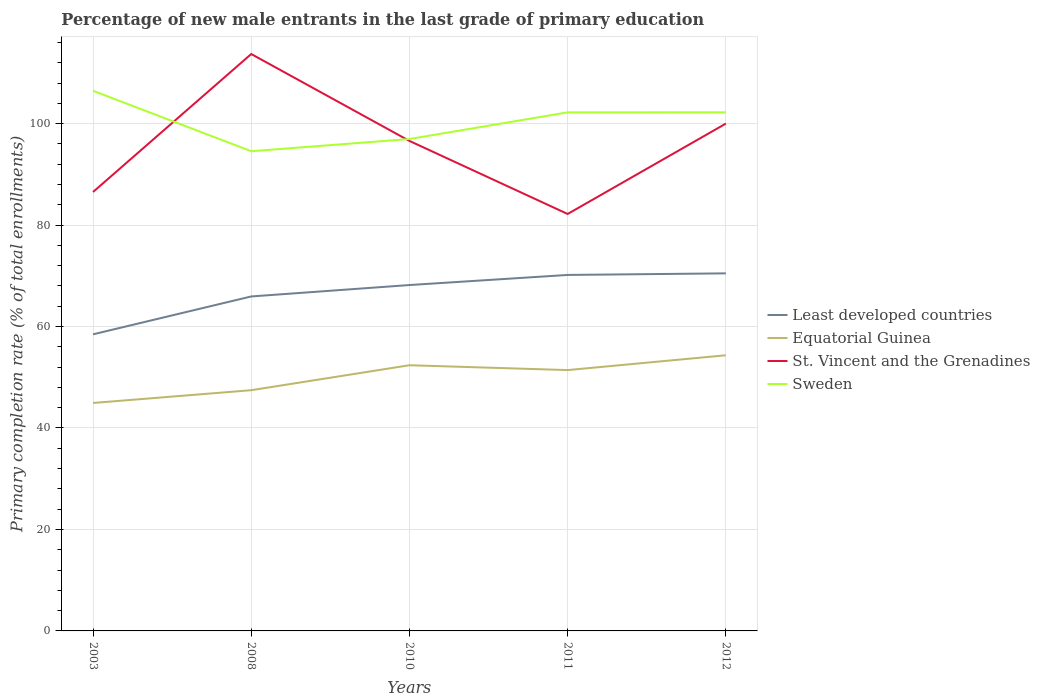Does the line corresponding to Least developed countries intersect with the line corresponding to St. Vincent and the Grenadines?
Your answer should be very brief. No. Is the number of lines equal to the number of legend labels?
Your response must be concise. Yes. Across all years, what is the maximum percentage of new male entrants in Least developed countries?
Your response must be concise. 58.46. What is the total percentage of new male entrants in Equatorial Guinea in the graph?
Your answer should be compact. -6.88. What is the difference between the highest and the second highest percentage of new male entrants in St. Vincent and the Grenadines?
Offer a terse response. 31.53. Is the percentage of new male entrants in Least developed countries strictly greater than the percentage of new male entrants in Sweden over the years?
Offer a very short reply. Yes. How many years are there in the graph?
Offer a very short reply. 5. Are the values on the major ticks of Y-axis written in scientific E-notation?
Your answer should be very brief. No. Does the graph contain any zero values?
Give a very brief answer. No. How are the legend labels stacked?
Keep it short and to the point. Vertical. What is the title of the graph?
Your answer should be compact. Percentage of new male entrants in the last grade of primary education. What is the label or title of the X-axis?
Ensure brevity in your answer.  Years. What is the label or title of the Y-axis?
Your answer should be very brief. Primary completion rate (% of total enrollments). What is the Primary completion rate (% of total enrollments) of Least developed countries in 2003?
Your answer should be compact. 58.46. What is the Primary completion rate (% of total enrollments) of Equatorial Guinea in 2003?
Your answer should be compact. 44.93. What is the Primary completion rate (% of total enrollments) in St. Vincent and the Grenadines in 2003?
Your answer should be very brief. 86.52. What is the Primary completion rate (% of total enrollments) of Sweden in 2003?
Offer a very short reply. 106.47. What is the Primary completion rate (% of total enrollments) of Least developed countries in 2008?
Your response must be concise. 65.93. What is the Primary completion rate (% of total enrollments) in Equatorial Guinea in 2008?
Provide a succinct answer. 47.45. What is the Primary completion rate (% of total enrollments) in St. Vincent and the Grenadines in 2008?
Your answer should be very brief. 113.72. What is the Primary completion rate (% of total enrollments) in Sweden in 2008?
Provide a succinct answer. 94.56. What is the Primary completion rate (% of total enrollments) in Least developed countries in 2010?
Keep it short and to the point. 68.18. What is the Primary completion rate (% of total enrollments) in Equatorial Guinea in 2010?
Your response must be concise. 52.37. What is the Primary completion rate (% of total enrollments) in St. Vincent and the Grenadines in 2010?
Your answer should be very brief. 96.59. What is the Primary completion rate (% of total enrollments) of Sweden in 2010?
Offer a terse response. 96.96. What is the Primary completion rate (% of total enrollments) in Least developed countries in 2011?
Your response must be concise. 70.17. What is the Primary completion rate (% of total enrollments) in Equatorial Guinea in 2011?
Make the answer very short. 51.42. What is the Primary completion rate (% of total enrollments) in St. Vincent and the Grenadines in 2011?
Ensure brevity in your answer.  82.19. What is the Primary completion rate (% of total enrollments) of Sweden in 2011?
Make the answer very short. 102.22. What is the Primary completion rate (% of total enrollments) of Least developed countries in 2012?
Provide a succinct answer. 70.48. What is the Primary completion rate (% of total enrollments) of Equatorial Guinea in 2012?
Offer a very short reply. 54.34. What is the Primary completion rate (% of total enrollments) of St. Vincent and the Grenadines in 2012?
Make the answer very short. 100. What is the Primary completion rate (% of total enrollments) of Sweden in 2012?
Provide a short and direct response. 102.23. Across all years, what is the maximum Primary completion rate (% of total enrollments) of Least developed countries?
Provide a short and direct response. 70.48. Across all years, what is the maximum Primary completion rate (% of total enrollments) of Equatorial Guinea?
Your answer should be compact. 54.34. Across all years, what is the maximum Primary completion rate (% of total enrollments) of St. Vincent and the Grenadines?
Provide a short and direct response. 113.72. Across all years, what is the maximum Primary completion rate (% of total enrollments) of Sweden?
Your response must be concise. 106.47. Across all years, what is the minimum Primary completion rate (% of total enrollments) of Least developed countries?
Provide a succinct answer. 58.46. Across all years, what is the minimum Primary completion rate (% of total enrollments) of Equatorial Guinea?
Give a very brief answer. 44.93. Across all years, what is the minimum Primary completion rate (% of total enrollments) of St. Vincent and the Grenadines?
Keep it short and to the point. 82.19. Across all years, what is the minimum Primary completion rate (% of total enrollments) of Sweden?
Your answer should be very brief. 94.56. What is the total Primary completion rate (% of total enrollments) of Least developed countries in the graph?
Give a very brief answer. 333.22. What is the total Primary completion rate (% of total enrollments) of Equatorial Guinea in the graph?
Ensure brevity in your answer.  250.51. What is the total Primary completion rate (% of total enrollments) in St. Vincent and the Grenadines in the graph?
Offer a terse response. 479.01. What is the total Primary completion rate (% of total enrollments) in Sweden in the graph?
Keep it short and to the point. 502.44. What is the difference between the Primary completion rate (% of total enrollments) in Least developed countries in 2003 and that in 2008?
Keep it short and to the point. -7.47. What is the difference between the Primary completion rate (% of total enrollments) of Equatorial Guinea in 2003 and that in 2008?
Make the answer very short. -2.52. What is the difference between the Primary completion rate (% of total enrollments) of St. Vincent and the Grenadines in 2003 and that in 2008?
Ensure brevity in your answer.  -27.2. What is the difference between the Primary completion rate (% of total enrollments) of Sweden in 2003 and that in 2008?
Your answer should be very brief. 11.91. What is the difference between the Primary completion rate (% of total enrollments) in Least developed countries in 2003 and that in 2010?
Offer a terse response. -9.72. What is the difference between the Primary completion rate (% of total enrollments) of Equatorial Guinea in 2003 and that in 2010?
Your answer should be very brief. -7.44. What is the difference between the Primary completion rate (% of total enrollments) of St. Vincent and the Grenadines in 2003 and that in 2010?
Keep it short and to the point. -10.07. What is the difference between the Primary completion rate (% of total enrollments) in Sweden in 2003 and that in 2010?
Keep it short and to the point. 9.51. What is the difference between the Primary completion rate (% of total enrollments) in Least developed countries in 2003 and that in 2011?
Give a very brief answer. -11.71. What is the difference between the Primary completion rate (% of total enrollments) in Equatorial Guinea in 2003 and that in 2011?
Offer a very short reply. -6.48. What is the difference between the Primary completion rate (% of total enrollments) in St. Vincent and the Grenadines in 2003 and that in 2011?
Offer a terse response. 4.33. What is the difference between the Primary completion rate (% of total enrollments) of Sweden in 2003 and that in 2011?
Offer a terse response. 4.25. What is the difference between the Primary completion rate (% of total enrollments) in Least developed countries in 2003 and that in 2012?
Give a very brief answer. -12.02. What is the difference between the Primary completion rate (% of total enrollments) in Equatorial Guinea in 2003 and that in 2012?
Your answer should be very brief. -9.4. What is the difference between the Primary completion rate (% of total enrollments) of St. Vincent and the Grenadines in 2003 and that in 2012?
Provide a short and direct response. -13.48. What is the difference between the Primary completion rate (% of total enrollments) in Sweden in 2003 and that in 2012?
Make the answer very short. 4.24. What is the difference between the Primary completion rate (% of total enrollments) in Least developed countries in 2008 and that in 2010?
Your answer should be compact. -2.25. What is the difference between the Primary completion rate (% of total enrollments) in Equatorial Guinea in 2008 and that in 2010?
Offer a very short reply. -4.92. What is the difference between the Primary completion rate (% of total enrollments) of St. Vincent and the Grenadines in 2008 and that in 2010?
Give a very brief answer. 17.13. What is the difference between the Primary completion rate (% of total enrollments) of Sweden in 2008 and that in 2010?
Provide a succinct answer. -2.41. What is the difference between the Primary completion rate (% of total enrollments) in Least developed countries in 2008 and that in 2011?
Your answer should be compact. -4.24. What is the difference between the Primary completion rate (% of total enrollments) of Equatorial Guinea in 2008 and that in 2011?
Offer a terse response. -3.97. What is the difference between the Primary completion rate (% of total enrollments) in St. Vincent and the Grenadines in 2008 and that in 2011?
Offer a very short reply. 31.53. What is the difference between the Primary completion rate (% of total enrollments) in Sweden in 2008 and that in 2011?
Give a very brief answer. -7.66. What is the difference between the Primary completion rate (% of total enrollments) in Least developed countries in 2008 and that in 2012?
Ensure brevity in your answer.  -4.55. What is the difference between the Primary completion rate (% of total enrollments) in Equatorial Guinea in 2008 and that in 2012?
Give a very brief answer. -6.88. What is the difference between the Primary completion rate (% of total enrollments) of St. Vincent and the Grenadines in 2008 and that in 2012?
Provide a succinct answer. 13.72. What is the difference between the Primary completion rate (% of total enrollments) of Sweden in 2008 and that in 2012?
Your response must be concise. -7.67. What is the difference between the Primary completion rate (% of total enrollments) in Least developed countries in 2010 and that in 2011?
Your response must be concise. -1.99. What is the difference between the Primary completion rate (% of total enrollments) of Equatorial Guinea in 2010 and that in 2011?
Your answer should be compact. 0.95. What is the difference between the Primary completion rate (% of total enrollments) in St. Vincent and the Grenadines in 2010 and that in 2011?
Give a very brief answer. 14.4. What is the difference between the Primary completion rate (% of total enrollments) in Sweden in 2010 and that in 2011?
Provide a succinct answer. -5.26. What is the difference between the Primary completion rate (% of total enrollments) in Least developed countries in 2010 and that in 2012?
Your answer should be compact. -2.3. What is the difference between the Primary completion rate (% of total enrollments) in Equatorial Guinea in 2010 and that in 2012?
Provide a succinct answer. -1.96. What is the difference between the Primary completion rate (% of total enrollments) in St. Vincent and the Grenadines in 2010 and that in 2012?
Keep it short and to the point. -3.41. What is the difference between the Primary completion rate (% of total enrollments) in Sweden in 2010 and that in 2012?
Your answer should be compact. -5.26. What is the difference between the Primary completion rate (% of total enrollments) of Least developed countries in 2011 and that in 2012?
Your answer should be compact. -0.31. What is the difference between the Primary completion rate (% of total enrollments) of Equatorial Guinea in 2011 and that in 2012?
Your answer should be compact. -2.92. What is the difference between the Primary completion rate (% of total enrollments) of St. Vincent and the Grenadines in 2011 and that in 2012?
Offer a terse response. -17.81. What is the difference between the Primary completion rate (% of total enrollments) in Sweden in 2011 and that in 2012?
Provide a short and direct response. -0.01. What is the difference between the Primary completion rate (% of total enrollments) in Least developed countries in 2003 and the Primary completion rate (% of total enrollments) in Equatorial Guinea in 2008?
Your answer should be compact. 11.01. What is the difference between the Primary completion rate (% of total enrollments) in Least developed countries in 2003 and the Primary completion rate (% of total enrollments) in St. Vincent and the Grenadines in 2008?
Offer a very short reply. -55.25. What is the difference between the Primary completion rate (% of total enrollments) of Least developed countries in 2003 and the Primary completion rate (% of total enrollments) of Sweden in 2008?
Offer a very short reply. -36.09. What is the difference between the Primary completion rate (% of total enrollments) in Equatorial Guinea in 2003 and the Primary completion rate (% of total enrollments) in St. Vincent and the Grenadines in 2008?
Make the answer very short. -68.78. What is the difference between the Primary completion rate (% of total enrollments) in Equatorial Guinea in 2003 and the Primary completion rate (% of total enrollments) in Sweden in 2008?
Offer a very short reply. -49.62. What is the difference between the Primary completion rate (% of total enrollments) of St. Vincent and the Grenadines in 2003 and the Primary completion rate (% of total enrollments) of Sweden in 2008?
Provide a succinct answer. -8.04. What is the difference between the Primary completion rate (% of total enrollments) in Least developed countries in 2003 and the Primary completion rate (% of total enrollments) in Equatorial Guinea in 2010?
Your response must be concise. 6.09. What is the difference between the Primary completion rate (% of total enrollments) of Least developed countries in 2003 and the Primary completion rate (% of total enrollments) of St. Vincent and the Grenadines in 2010?
Your answer should be very brief. -38.13. What is the difference between the Primary completion rate (% of total enrollments) of Least developed countries in 2003 and the Primary completion rate (% of total enrollments) of Sweden in 2010?
Keep it short and to the point. -38.5. What is the difference between the Primary completion rate (% of total enrollments) of Equatorial Guinea in 2003 and the Primary completion rate (% of total enrollments) of St. Vincent and the Grenadines in 2010?
Keep it short and to the point. -51.65. What is the difference between the Primary completion rate (% of total enrollments) in Equatorial Guinea in 2003 and the Primary completion rate (% of total enrollments) in Sweden in 2010?
Make the answer very short. -52.03. What is the difference between the Primary completion rate (% of total enrollments) of St. Vincent and the Grenadines in 2003 and the Primary completion rate (% of total enrollments) of Sweden in 2010?
Your answer should be compact. -10.44. What is the difference between the Primary completion rate (% of total enrollments) of Least developed countries in 2003 and the Primary completion rate (% of total enrollments) of Equatorial Guinea in 2011?
Give a very brief answer. 7.05. What is the difference between the Primary completion rate (% of total enrollments) in Least developed countries in 2003 and the Primary completion rate (% of total enrollments) in St. Vincent and the Grenadines in 2011?
Keep it short and to the point. -23.73. What is the difference between the Primary completion rate (% of total enrollments) of Least developed countries in 2003 and the Primary completion rate (% of total enrollments) of Sweden in 2011?
Provide a succinct answer. -43.76. What is the difference between the Primary completion rate (% of total enrollments) in Equatorial Guinea in 2003 and the Primary completion rate (% of total enrollments) in St. Vincent and the Grenadines in 2011?
Provide a short and direct response. -37.26. What is the difference between the Primary completion rate (% of total enrollments) in Equatorial Guinea in 2003 and the Primary completion rate (% of total enrollments) in Sweden in 2011?
Make the answer very short. -57.29. What is the difference between the Primary completion rate (% of total enrollments) in St. Vincent and the Grenadines in 2003 and the Primary completion rate (% of total enrollments) in Sweden in 2011?
Your response must be concise. -15.7. What is the difference between the Primary completion rate (% of total enrollments) in Least developed countries in 2003 and the Primary completion rate (% of total enrollments) in Equatorial Guinea in 2012?
Provide a succinct answer. 4.13. What is the difference between the Primary completion rate (% of total enrollments) in Least developed countries in 2003 and the Primary completion rate (% of total enrollments) in St. Vincent and the Grenadines in 2012?
Provide a short and direct response. -41.54. What is the difference between the Primary completion rate (% of total enrollments) of Least developed countries in 2003 and the Primary completion rate (% of total enrollments) of Sweden in 2012?
Offer a terse response. -43.77. What is the difference between the Primary completion rate (% of total enrollments) of Equatorial Guinea in 2003 and the Primary completion rate (% of total enrollments) of St. Vincent and the Grenadines in 2012?
Your response must be concise. -55.07. What is the difference between the Primary completion rate (% of total enrollments) of Equatorial Guinea in 2003 and the Primary completion rate (% of total enrollments) of Sweden in 2012?
Offer a terse response. -57.29. What is the difference between the Primary completion rate (% of total enrollments) in St. Vincent and the Grenadines in 2003 and the Primary completion rate (% of total enrollments) in Sweden in 2012?
Give a very brief answer. -15.71. What is the difference between the Primary completion rate (% of total enrollments) in Least developed countries in 2008 and the Primary completion rate (% of total enrollments) in Equatorial Guinea in 2010?
Ensure brevity in your answer.  13.56. What is the difference between the Primary completion rate (% of total enrollments) of Least developed countries in 2008 and the Primary completion rate (% of total enrollments) of St. Vincent and the Grenadines in 2010?
Your response must be concise. -30.66. What is the difference between the Primary completion rate (% of total enrollments) in Least developed countries in 2008 and the Primary completion rate (% of total enrollments) in Sweden in 2010?
Keep it short and to the point. -31.03. What is the difference between the Primary completion rate (% of total enrollments) of Equatorial Guinea in 2008 and the Primary completion rate (% of total enrollments) of St. Vincent and the Grenadines in 2010?
Your answer should be very brief. -49.14. What is the difference between the Primary completion rate (% of total enrollments) of Equatorial Guinea in 2008 and the Primary completion rate (% of total enrollments) of Sweden in 2010?
Provide a short and direct response. -49.51. What is the difference between the Primary completion rate (% of total enrollments) in St. Vincent and the Grenadines in 2008 and the Primary completion rate (% of total enrollments) in Sweden in 2010?
Provide a succinct answer. 16.75. What is the difference between the Primary completion rate (% of total enrollments) in Least developed countries in 2008 and the Primary completion rate (% of total enrollments) in Equatorial Guinea in 2011?
Your answer should be compact. 14.51. What is the difference between the Primary completion rate (% of total enrollments) in Least developed countries in 2008 and the Primary completion rate (% of total enrollments) in St. Vincent and the Grenadines in 2011?
Ensure brevity in your answer.  -16.26. What is the difference between the Primary completion rate (% of total enrollments) of Least developed countries in 2008 and the Primary completion rate (% of total enrollments) of Sweden in 2011?
Your answer should be very brief. -36.29. What is the difference between the Primary completion rate (% of total enrollments) in Equatorial Guinea in 2008 and the Primary completion rate (% of total enrollments) in St. Vincent and the Grenadines in 2011?
Your answer should be compact. -34.74. What is the difference between the Primary completion rate (% of total enrollments) in Equatorial Guinea in 2008 and the Primary completion rate (% of total enrollments) in Sweden in 2011?
Give a very brief answer. -54.77. What is the difference between the Primary completion rate (% of total enrollments) of St. Vincent and the Grenadines in 2008 and the Primary completion rate (% of total enrollments) of Sweden in 2011?
Your response must be concise. 11.5. What is the difference between the Primary completion rate (% of total enrollments) in Least developed countries in 2008 and the Primary completion rate (% of total enrollments) in Equatorial Guinea in 2012?
Your answer should be compact. 11.59. What is the difference between the Primary completion rate (% of total enrollments) of Least developed countries in 2008 and the Primary completion rate (% of total enrollments) of St. Vincent and the Grenadines in 2012?
Keep it short and to the point. -34.07. What is the difference between the Primary completion rate (% of total enrollments) of Least developed countries in 2008 and the Primary completion rate (% of total enrollments) of Sweden in 2012?
Your response must be concise. -36.3. What is the difference between the Primary completion rate (% of total enrollments) of Equatorial Guinea in 2008 and the Primary completion rate (% of total enrollments) of St. Vincent and the Grenadines in 2012?
Your response must be concise. -52.55. What is the difference between the Primary completion rate (% of total enrollments) in Equatorial Guinea in 2008 and the Primary completion rate (% of total enrollments) in Sweden in 2012?
Ensure brevity in your answer.  -54.78. What is the difference between the Primary completion rate (% of total enrollments) of St. Vincent and the Grenadines in 2008 and the Primary completion rate (% of total enrollments) of Sweden in 2012?
Offer a very short reply. 11.49. What is the difference between the Primary completion rate (% of total enrollments) of Least developed countries in 2010 and the Primary completion rate (% of total enrollments) of Equatorial Guinea in 2011?
Provide a succinct answer. 16.76. What is the difference between the Primary completion rate (% of total enrollments) of Least developed countries in 2010 and the Primary completion rate (% of total enrollments) of St. Vincent and the Grenadines in 2011?
Keep it short and to the point. -14.01. What is the difference between the Primary completion rate (% of total enrollments) in Least developed countries in 2010 and the Primary completion rate (% of total enrollments) in Sweden in 2011?
Your response must be concise. -34.04. What is the difference between the Primary completion rate (% of total enrollments) in Equatorial Guinea in 2010 and the Primary completion rate (% of total enrollments) in St. Vincent and the Grenadines in 2011?
Keep it short and to the point. -29.82. What is the difference between the Primary completion rate (% of total enrollments) of Equatorial Guinea in 2010 and the Primary completion rate (% of total enrollments) of Sweden in 2011?
Make the answer very short. -49.85. What is the difference between the Primary completion rate (% of total enrollments) in St. Vincent and the Grenadines in 2010 and the Primary completion rate (% of total enrollments) in Sweden in 2011?
Make the answer very short. -5.63. What is the difference between the Primary completion rate (% of total enrollments) of Least developed countries in 2010 and the Primary completion rate (% of total enrollments) of Equatorial Guinea in 2012?
Keep it short and to the point. 13.84. What is the difference between the Primary completion rate (% of total enrollments) in Least developed countries in 2010 and the Primary completion rate (% of total enrollments) in St. Vincent and the Grenadines in 2012?
Your response must be concise. -31.82. What is the difference between the Primary completion rate (% of total enrollments) in Least developed countries in 2010 and the Primary completion rate (% of total enrollments) in Sweden in 2012?
Your answer should be very brief. -34.05. What is the difference between the Primary completion rate (% of total enrollments) in Equatorial Guinea in 2010 and the Primary completion rate (% of total enrollments) in St. Vincent and the Grenadines in 2012?
Make the answer very short. -47.63. What is the difference between the Primary completion rate (% of total enrollments) in Equatorial Guinea in 2010 and the Primary completion rate (% of total enrollments) in Sweden in 2012?
Keep it short and to the point. -49.86. What is the difference between the Primary completion rate (% of total enrollments) of St. Vincent and the Grenadines in 2010 and the Primary completion rate (% of total enrollments) of Sweden in 2012?
Offer a very short reply. -5.64. What is the difference between the Primary completion rate (% of total enrollments) of Least developed countries in 2011 and the Primary completion rate (% of total enrollments) of Equatorial Guinea in 2012?
Provide a succinct answer. 15.83. What is the difference between the Primary completion rate (% of total enrollments) of Least developed countries in 2011 and the Primary completion rate (% of total enrollments) of St. Vincent and the Grenadines in 2012?
Ensure brevity in your answer.  -29.83. What is the difference between the Primary completion rate (% of total enrollments) in Least developed countries in 2011 and the Primary completion rate (% of total enrollments) in Sweden in 2012?
Your answer should be compact. -32.06. What is the difference between the Primary completion rate (% of total enrollments) of Equatorial Guinea in 2011 and the Primary completion rate (% of total enrollments) of St. Vincent and the Grenadines in 2012?
Your answer should be compact. -48.58. What is the difference between the Primary completion rate (% of total enrollments) in Equatorial Guinea in 2011 and the Primary completion rate (% of total enrollments) in Sweden in 2012?
Ensure brevity in your answer.  -50.81. What is the difference between the Primary completion rate (% of total enrollments) of St. Vincent and the Grenadines in 2011 and the Primary completion rate (% of total enrollments) of Sweden in 2012?
Your answer should be very brief. -20.04. What is the average Primary completion rate (% of total enrollments) of Least developed countries per year?
Provide a short and direct response. 66.64. What is the average Primary completion rate (% of total enrollments) of Equatorial Guinea per year?
Ensure brevity in your answer.  50.1. What is the average Primary completion rate (% of total enrollments) in St. Vincent and the Grenadines per year?
Give a very brief answer. 95.8. What is the average Primary completion rate (% of total enrollments) of Sweden per year?
Ensure brevity in your answer.  100.49. In the year 2003, what is the difference between the Primary completion rate (% of total enrollments) of Least developed countries and Primary completion rate (% of total enrollments) of Equatorial Guinea?
Offer a terse response. 13.53. In the year 2003, what is the difference between the Primary completion rate (% of total enrollments) of Least developed countries and Primary completion rate (% of total enrollments) of St. Vincent and the Grenadines?
Offer a very short reply. -28.06. In the year 2003, what is the difference between the Primary completion rate (% of total enrollments) in Least developed countries and Primary completion rate (% of total enrollments) in Sweden?
Your response must be concise. -48.01. In the year 2003, what is the difference between the Primary completion rate (% of total enrollments) in Equatorial Guinea and Primary completion rate (% of total enrollments) in St. Vincent and the Grenadines?
Provide a succinct answer. -41.59. In the year 2003, what is the difference between the Primary completion rate (% of total enrollments) of Equatorial Guinea and Primary completion rate (% of total enrollments) of Sweden?
Provide a succinct answer. -61.54. In the year 2003, what is the difference between the Primary completion rate (% of total enrollments) of St. Vincent and the Grenadines and Primary completion rate (% of total enrollments) of Sweden?
Provide a succinct answer. -19.95. In the year 2008, what is the difference between the Primary completion rate (% of total enrollments) of Least developed countries and Primary completion rate (% of total enrollments) of Equatorial Guinea?
Offer a very short reply. 18.48. In the year 2008, what is the difference between the Primary completion rate (% of total enrollments) of Least developed countries and Primary completion rate (% of total enrollments) of St. Vincent and the Grenadines?
Offer a terse response. -47.79. In the year 2008, what is the difference between the Primary completion rate (% of total enrollments) of Least developed countries and Primary completion rate (% of total enrollments) of Sweden?
Your response must be concise. -28.63. In the year 2008, what is the difference between the Primary completion rate (% of total enrollments) of Equatorial Guinea and Primary completion rate (% of total enrollments) of St. Vincent and the Grenadines?
Make the answer very short. -66.27. In the year 2008, what is the difference between the Primary completion rate (% of total enrollments) in Equatorial Guinea and Primary completion rate (% of total enrollments) in Sweden?
Keep it short and to the point. -47.11. In the year 2008, what is the difference between the Primary completion rate (% of total enrollments) in St. Vincent and the Grenadines and Primary completion rate (% of total enrollments) in Sweden?
Ensure brevity in your answer.  19.16. In the year 2010, what is the difference between the Primary completion rate (% of total enrollments) in Least developed countries and Primary completion rate (% of total enrollments) in Equatorial Guinea?
Ensure brevity in your answer.  15.81. In the year 2010, what is the difference between the Primary completion rate (% of total enrollments) in Least developed countries and Primary completion rate (% of total enrollments) in St. Vincent and the Grenadines?
Ensure brevity in your answer.  -28.41. In the year 2010, what is the difference between the Primary completion rate (% of total enrollments) in Least developed countries and Primary completion rate (% of total enrollments) in Sweden?
Provide a succinct answer. -28.78. In the year 2010, what is the difference between the Primary completion rate (% of total enrollments) of Equatorial Guinea and Primary completion rate (% of total enrollments) of St. Vincent and the Grenadines?
Offer a very short reply. -44.22. In the year 2010, what is the difference between the Primary completion rate (% of total enrollments) of Equatorial Guinea and Primary completion rate (% of total enrollments) of Sweden?
Keep it short and to the point. -44.59. In the year 2010, what is the difference between the Primary completion rate (% of total enrollments) in St. Vincent and the Grenadines and Primary completion rate (% of total enrollments) in Sweden?
Your response must be concise. -0.38. In the year 2011, what is the difference between the Primary completion rate (% of total enrollments) of Least developed countries and Primary completion rate (% of total enrollments) of Equatorial Guinea?
Your answer should be very brief. 18.75. In the year 2011, what is the difference between the Primary completion rate (% of total enrollments) in Least developed countries and Primary completion rate (% of total enrollments) in St. Vincent and the Grenadines?
Your response must be concise. -12.02. In the year 2011, what is the difference between the Primary completion rate (% of total enrollments) of Least developed countries and Primary completion rate (% of total enrollments) of Sweden?
Offer a very short reply. -32.05. In the year 2011, what is the difference between the Primary completion rate (% of total enrollments) of Equatorial Guinea and Primary completion rate (% of total enrollments) of St. Vincent and the Grenadines?
Keep it short and to the point. -30.77. In the year 2011, what is the difference between the Primary completion rate (% of total enrollments) of Equatorial Guinea and Primary completion rate (% of total enrollments) of Sweden?
Your answer should be compact. -50.8. In the year 2011, what is the difference between the Primary completion rate (% of total enrollments) in St. Vincent and the Grenadines and Primary completion rate (% of total enrollments) in Sweden?
Provide a succinct answer. -20.03. In the year 2012, what is the difference between the Primary completion rate (% of total enrollments) of Least developed countries and Primary completion rate (% of total enrollments) of Equatorial Guinea?
Offer a terse response. 16.15. In the year 2012, what is the difference between the Primary completion rate (% of total enrollments) of Least developed countries and Primary completion rate (% of total enrollments) of St. Vincent and the Grenadines?
Keep it short and to the point. -29.52. In the year 2012, what is the difference between the Primary completion rate (% of total enrollments) in Least developed countries and Primary completion rate (% of total enrollments) in Sweden?
Your response must be concise. -31.74. In the year 2012, what is the difference between the Primary completion rate (% of total enrollments) of Equatorial Guinea and Primary completion rate (% of total enrollments) of St. Vincent and the Grenadines?
Keep it short and to the point. -45.66. In the year 2012, what is the difference between the Primary completion rate (% of total enrollments) of Equatorial Guinea and Primary completion rate (% of total enrollments) of Sweden?
Give a very brief answer. -47.89. In the year 2012, what is the difference between the Primary completion rate (% of total enrollments) of St. Vincent and the Grenadines and Primary completion rate (% of total enrollments) of Sweden?
Give a very brief answer. -2.23. What is the ratio of the Primary completion rate (% of total enrollments) of Least developed countries in 2003 to that in 2008?
Make the answer very short. 0.89. What is the ratio of the Primary completion rate (% of total enrollments) in Equatorial Guinea in 2003 to that in 2008?
Offer a terse response. 0.95. What is the ratio of the Primary completion rate (% of total enrollments) of St. Vincent and the Grenadines in 2003 to that in 2008?
Offer a terse response. 0.76. What is the ratio of the Primary completion rate (% of total enrollments) in Sweden in 2003 to that in 2008?
Ensure brevity in your answer.  1.13. What is the ratio of the Primary completion rate (% of total enrollments) of Least developed countries in 2003 to that in 2010?
Your answer should be compact. 0.86. What is the ratio of the Primary completion rate (% of total enrollments) in Equatorial Guinea in 2003 to that in 2010?
Offer a terse response. 0.86. What is the ratio of the Primary completion rate (% of total enrollments) in St. Vincent and the Grenadines in 2003 to that in 2010?
Your answer should be very brief. 0.9. What is the ratio of the Primary completion rate (% of total enrollments) of Sweden in 2003 to that in 2010?
Give a very brief answer. 1.1. What is the ratio of the Primary completion rate (% of total enrollments) of Least developed countries in 2003 to that in 2011?
Offer a very short reply. 0.83. What is the ratio of the Primary completion rate (% of total enrollments) in Equatorial Guinea in 2003 to that in 2011?
Provide a succinct answer. 0.87. What is the ratio of the Primary completion rate (% of total enrollments) in St. Vincent and the Grenadines in 2003 to that in 2011?
Provide a short and direct response. 1.05. What is the ratio of the Primary completion rate (% of total enrollments) in Sweden in 2003 to that in 2011?
Provide a short and direct response. 1.04. What is the ratio of the Primary completion rate (% of total enrollments) of Least developed countries in 2003 to that in 2012?
Make the answer very short. 0.83. What is the ratio of the Primary completion rate (% of total enrollments) in Equatorial Guinea in 2003 to that in 2012?
Ensure brevity in your answer.  0.83. What is the ratio of the Primary completion rate (% of total enrollments) of St. Vincent and the Grenadines in 2003 to that in 2012?
Keep it short and to the point. 0.87. What is the ratio of the Primary completion rate (% of total enrollments) of Sweden in 2003 to that in 2012?
Keep it short and to the point. 1.04. What is the ratio of the Primary completion rate (% of total enrollments) in Equatorial Guinea in 2008 to that in 2010?
Ensure brevity in your answer.  0.91. What is the ratio of the Primary completion rate (% of total enrollments) in St. Vincent and the Grenadines in 2008 to that in 2010?
Keep it short and to the point. 1.18. What is the ratio of the Primary completion rate (% of total enrollments) of Sweden in 2008 to that in 2010?
Offer a terse response. 0.98. What is the ratio of the Primary completion rate (% of total enrollments) in Least developed countries in 2008 to that in 2011?
Provide a succinct answer. 0.94. What is the ratio of the Primary completion rate (% of total enrollments) in Equatorial Guinea in 2008 to that in 2011?
Make the answer very short. 0.92. What is the ratio of the Primary completion rate (% of total enrollments) in St. Vincent and the Grenadines in 2008 to that in 2011?
Make the answer very short. 1.38. What is the ratio of the Primary completion rate (% of total enrollments) in Sweden in 2008 to that in 2011?
Provide a succinct answer. 0.93. What is the ratio of the Primary completion rate (% of total enrollments) in Least developed countries in 2008 to that in 2012?
Provide a succinct answer. 0.94. What is the ratio of the Primary completion rate (% of total enrollments) of Equatorial Guinea in 2008 to that in 2012?
Give a very brief answer. 0.87. What is the ratio of the Primary completion rate (% of total enrollments) of St. Vincent and the Grenadines in 2008 to that in 2012?
Your answer should be very brief. 1.14. What is the ratio of the Primary completion rate (% of total enrollments) in Sweden in 2008 to that in 2012?
Ensure brevity in your answer.  0.93. What is the ratio of the Primary completion rate (% of total enrollments) in Least developed countries in 2010 to that in 2011?
Provide a succinct answer. 0.97. What is the ratio of the Primary completion rate (% of total enrollments) in Equatorial Guinea in 2010 to that in 2011?
Offer a very short reply. 1.02. What is the ratio of the Primary completion rate (% of total enrollments) of St. Vincent and the Grenadines in 2010 to that in 2011?
Provide a short and direct response. 1.18. What is the ratio of the Primary completion rate (% of total enrollments) in Sweden in 2010 to that in 2011?
Make the answer very short. 0.95. What is the ratio of the Primary completion rate (% of total enrollments) in Least developed countries in 2010 to that in 2012?
Offer a terse response. 0.97. What is the ratio of the Primary completion rate (% of total enrollments) in Equatorial Guinea in 2010 to that in 2012?
Ensure brevity in your answer.  0.96. What is the ratio of the Primary completion rate (% of total enrollments) in St. Vincent and the Grenadines in 2010 to that in 2012?
Make the answer very short. 0.97. What is the ratio of the Primary completion rate (% of total enrollments) in Sweden in 2010 to that in 2012?
Make the answer very short. 0.95. What is the ratio of the Primary completion rate (% of total enrollments) of Equatorial Guinea in 2011 to that in 2012?
Offer a terse response. 0.95. What is the ratio of the Primary completion rate (% of total enrollments) of St. Vincent and the Grenadines in 2011 to that in 2012?
Offer a terse response. 0.82. What is the ratio of the Primary completion rate (% of total enrollments) of Sweden in 2011 to that in 2012?
Your answer should be very brief. 1. What is the difference between the highest and the second highest Primary completion rate (% of total enrollments) of Least developed countries?
Your response must be concise. 0.31. What is the difference between the highest and the second highest Primary completion rate (% of total enrollments) in Equatorial Guinea?
Provide a short and direct response. 1.96. What is the difference between the highest and the second highest Primary completion rate (% of total enrollments) in St. Vincent and the Grenadines?
Offer a very short reply. 13.72. What is the difference between the highest and the second highest Primary completion rate (% of total enrollments) of Sweden?
Your response must be concise. 4.24. What is the difference between the highest and the lowest Primary completion rate (% of total enrollments) in Least developed countries?
Give a very brief answer. 12.02. What is the difference between the highest and the lowest Primary completion rate (% of total enrollments) in Equatorial Guinea?
Your answer should be very brief. 9.4. What is the difference between the highest and the lowest Primary completion rate (% of total enrollments) in St. Vincent and the Grenadines?
Ensure brevity in your answer.  31.53. What is the difference between the highest and the lowest Primary completion rate (% of total enrollments) of Sweden?
Offer a terse response. 11.91. 